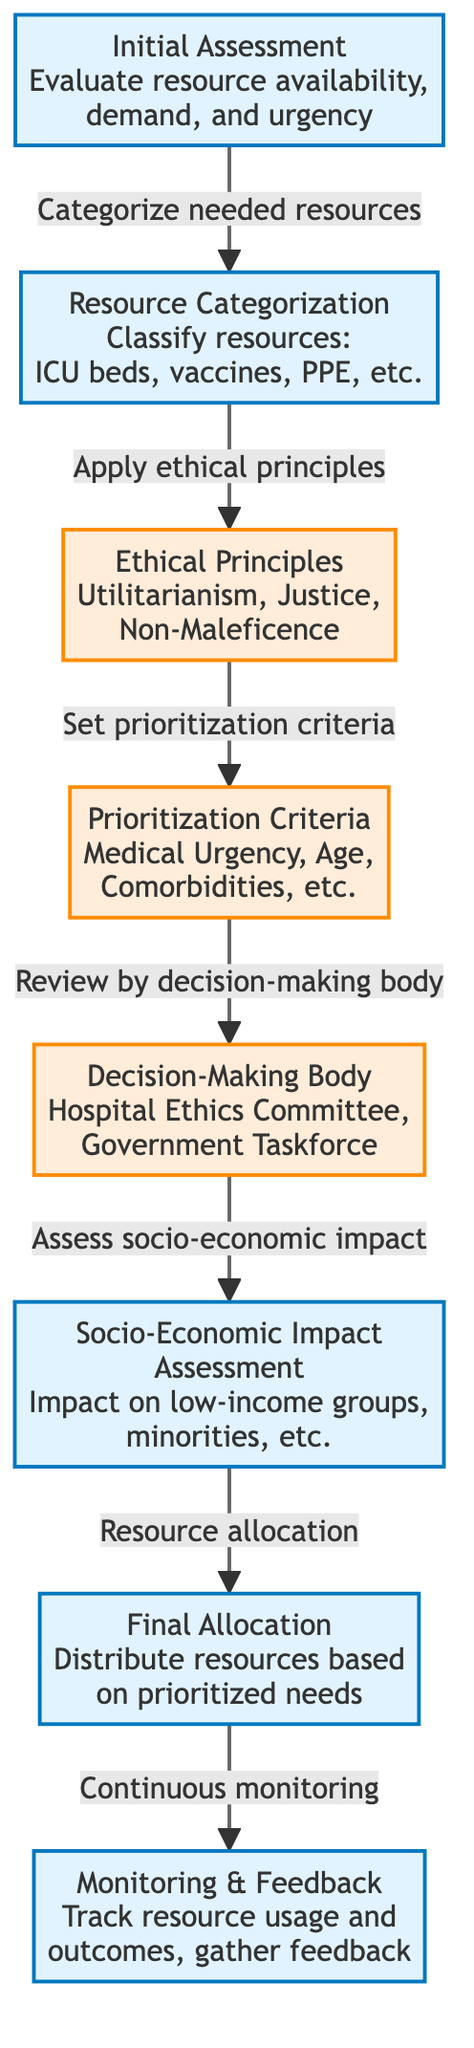What is the first step in the resource allocation process? The diagram indicates that the first step is "Initial Assessment" where resources availability, demand, and urgency are evaluated.
Answer: Initial Assessment How many prioritization criteria are listed in the diagram? The diagram shows one node for "Prioritization Criteria," which includes multiple criteria such as medical urgency, age, and comorbidities, but is labeled as a single node.
Answer: One What ethical principle is applied after resource categorization? After the node "Resource Categorization," the next node in the flow is "Ethical Principles." This node includes principles like utilitarianism, justice, and non-maleficence.
Answer: Ethical Principles What is the final step after monitoring & feedback? The final step mentioned in the diagram is "Final Allocation," where resources are distributed based on prioritized needs. This implies "Final Allocation" occurs before the monitoring process.
Answer: Final Allocation Which body is responsible for reviewing the prioritization criteria? The diagram includes a decision-making node labeled "Decision-Making Body," which specifically mentions the "Hospital Ethics Committee" and "Government Taskforce" as responsible for this review.
Answer: Decision-Making Body Explain the relationship between socio-economic impact assessment and resource allocation. According to the diagram, the "Socio-Economic Impact Assessment" node comes before the "Final Allocation" node. This means that the assessment influences the final distribution of resources based on their impact on specific groups, such as low-income individuals and minorities.
Answer: Assessment before allocation What follows after the 'Decision-Making Body' reviews the prioritization criteria? The diagram outlines that after reviewing by the "Decision-Making Body," the next step is to assess the socio-economic impact, which feeds into the resource allocation process.
Answer: Assess socio-economic impact How many processes are outlined in the diagram? The diagram delineates distinct nodes labeled as processes. There are five process nodes: "Initial Assessment," "Resource Categorization," "Socio-Economic Impact Assessment," "Final Allocation," and "Monitoring & Feedback." Therefore, the total number of process nodes is five.
Answer: Five What principle emphasizes the least harm in health resource allocation? The node labeled "Ethical Principles" contains "Non-Maleficence," which specifically emphasizes the principle of doing no harm in the allocation process.
Answer: Non-Maleficence 